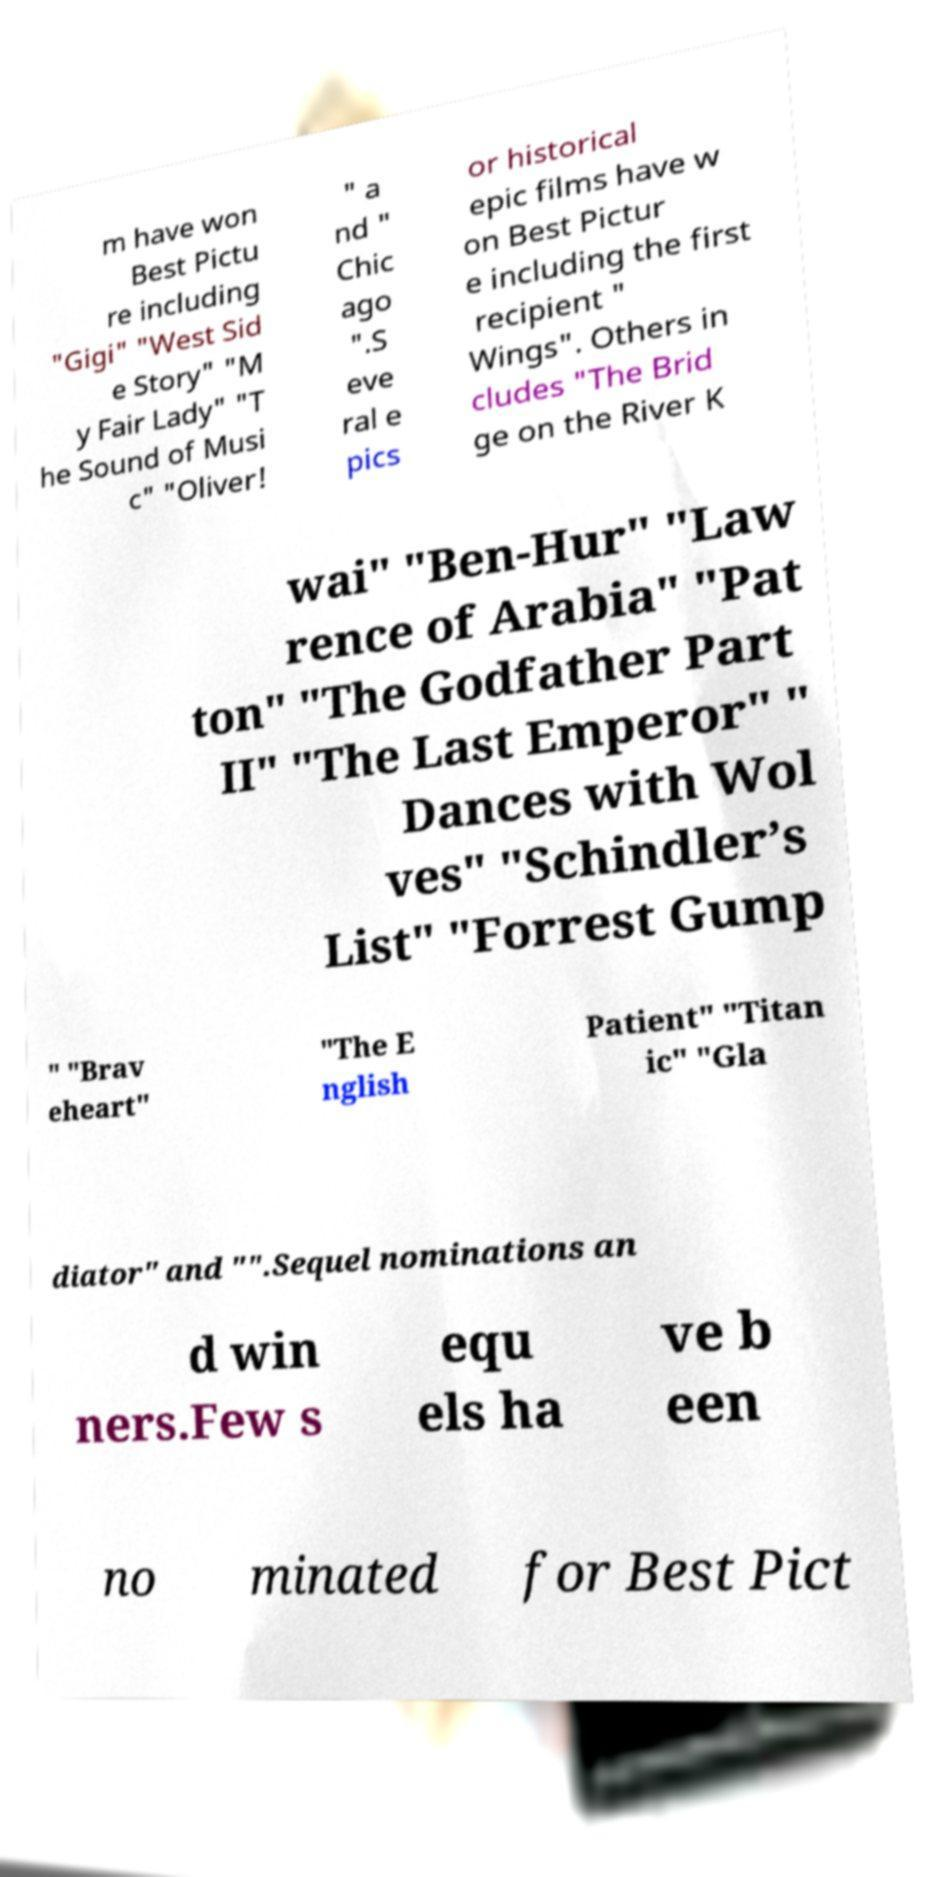Could you assist in decoding the text presented in this image and type it out clearly? m have won Best Pictu re including "Gigi" "West Sid e Story" "M y Fair Lady" "T he Sound of Musi c" "Oliver! " a nd " Chic ago ".S eve ral e pics or historical epic films have w on Best Pictur e including the first recipient " Wings". Others in cludes "The Brid ge on the River K wai" "Ben-Hur" "Law rence of Arabia" "Pat ton" "The Godfather Part II" "The Last Emperor" " Dances with Wol ves" "Schindler’s List" "Forrest Gump " "Brav eheart" "The E nglish Patient" "Titan ic" "Gla diator" and "".Sequel nominations an d win ners.Few s equ els ha ve b een no minated for Best Pict 